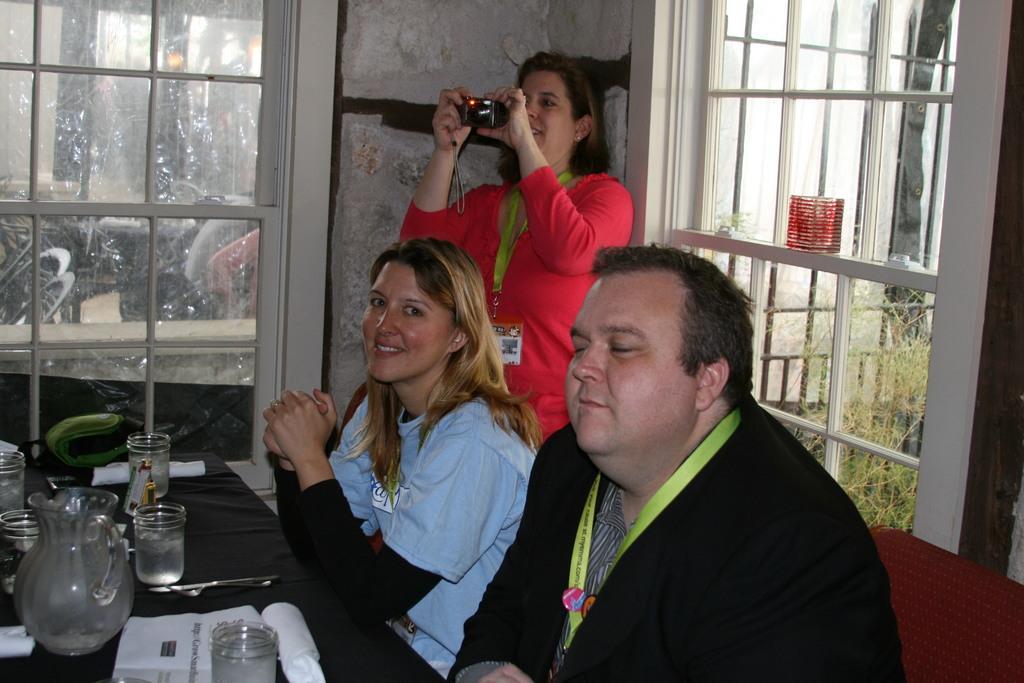Can you describe this image briefly? In this picture we can see there are two persons sitting and a woman is holding a camera. In front of the people, there is a table and on the table there are glasses, spoons, a jar and some objects. Behind the people, there are windows and wall. On the right side of the image, we can see a plant through a window. 